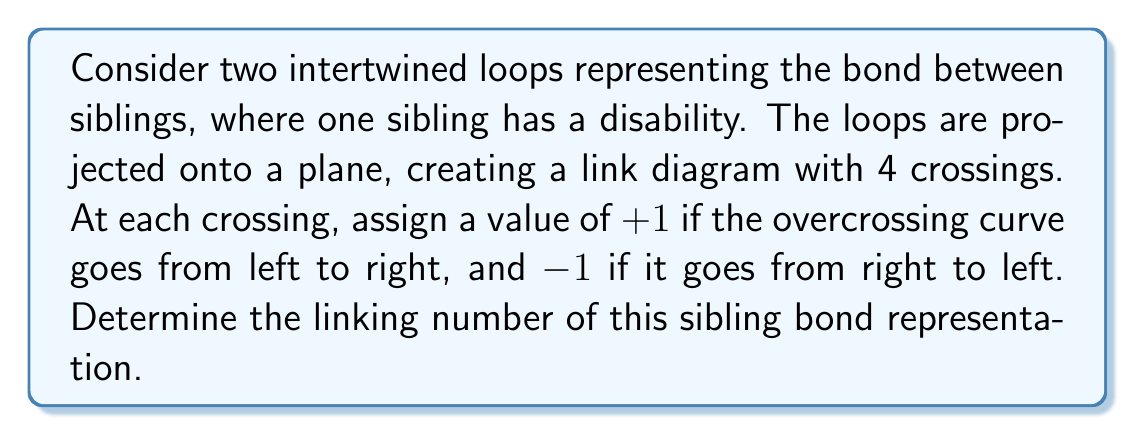Can you solve this math problem? To solve this problem, we'll follow these steps:

1. Understand the concept of linking number:
   The linking number is a topological invariant that measures how two curves are linked in three-dimensional space. It can be calculated from a projection of the link onto a plane.

2. Analyze the given information:
   - We have two intertwined loops representing sibling bonds.
   - The projection has 4 crossings.
   - Each crossing is assigned a value based on the direction of the overcrossing curve.

3. Calculate the linking number:
   The formula for the linking number is:
   
   $$ \text{Lk} = \frac{1}{2} \sum_{i} \epsilon_i $$
   
   Where $\epsilon_i$ is the value (+1 or -1) assigned to each crossing.

4. Assign values to crossings:
   Let's assume we have the following crossing values:
   Crossing 1: +1
   Crossing 2: -1
   Crossing 3: +1
   Crossing 4: +1

5. Apply the formula:
   $$ \text{Lk} = \frac{1}{2} (+1 + (-1) + 1 + 1) $$
   $$ \text{Lk} = \frac{1}{2} (2) $$
   $$ \text{Lk} = 1 $$

The linking number of 1 indicates that the loops are linked once, symbolizing a strong bond between the siblings.
Answer: 1 